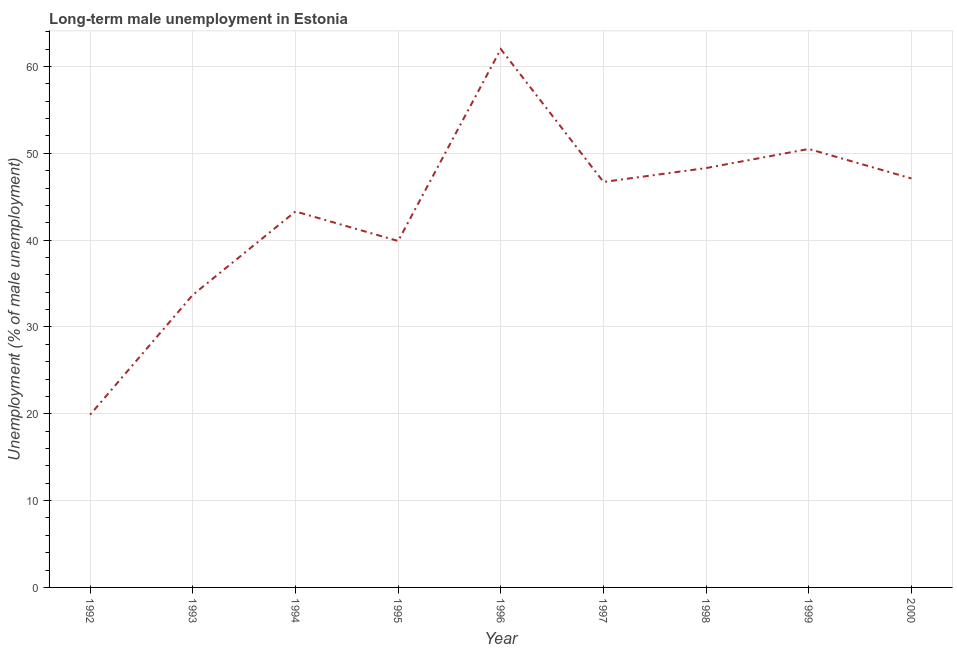What is the long-term male unemployment in 1998?
Ensure brevity in your answer.  48.3. Across all years, what is the minimum long-term male unemployment?
Your answer should be compact. 19.9. In which year was the long-term male unemployment maximum?
Offer a terse response. 1996. What is the sum of the long-term male unemployment?
Give a very brief answer. 391.4. What is the difference between the long-term male unemployment in 1994 and 1995?
Provide a short and direct response. 3.4. What is the average long-term male unemployment per year?
Give a very brief answer. 43.49. What is the median long-term male unemployment?
Offer a terse response. 46.7. In how many years, is the long-term male unemployment greater than 28 %?
Provide a short and direct response. 8. What is the ratio of the long-term male unemployment in 1997 to that in 1999?
Provide a succinct answer. 0.92. Is the long-term male unemployment in 1996 less than that in 1999?
Provide a succinct answer. No. What is the difference between the highest and the lowest long-term male unemployment?
Your answer should be compact. 42.1. In how many years, is the long-term male unemployment greater than the average long-term male unemployment taken over all years?
Your response must be concise. 5. How many lines are there?
Offer a terse response. 1. How many years are there in the graph?
Provide a succinct answer. 9. What is the difference between two consecutive major ticks on the Y-axis?
Make the answer very short. 10. Does the graph contain any zero values?
Make the answer very short. No. What is the title of the graph?
Provide a short and direct response. Long-term male unemployment in Estonia. What is the label or title of the X-axis?
Provide a succinct answer. Year. What is the label or title of the Y-axis?
Your response must be concise. Unemployment (% of male unemployment). What is the Unemployment (% of male unemployment) in 1992?
Make the answer very short. 19.9. What is the Unemployment (% of male unemployment) in 1993?
Your response must be concise. 33.7. What is the Unemployment (% of male unemployment) of 1994?
Offer a very short reply. 43.3. What is the Unemployment (% of male unemployment) in 1995?
Your response must be concise. 39.9. What is the Unemployment (% of male unemployment) in 1997?
Offer a terse response. 46.7. What is the Unemployment (% of male unemployment) of 1998?
Offer a terse response. 48.3. What is the Unemployment (% of male unemployment) of 1999?
Provide a short and direct response. 50.5. What is the Unemployment (% of male unemployment) of 2000?
Provide a short and direct response. 47.1. What is the difference between the Unemployment (% of male unemployment) in 1992 and 1993?
Keep it short and to the point. -13.8. What is the difference between the Unemployment (% of male unemployment) in 1992 and 1994?
Your response must be concise. -23.4. What is the difference between the Unemployment (% of male unemployment) in 1992 and 1996?
Offer a very short reply. -42.1. What is the difference between the Unemployment (% of male unemployment) in 1992 and 1997?
Offer a terse response. -26.8. What is the difference between the Unemployment (% of male unemployment) in 1992 and 1998?
Give a very brief answer. -28.4. What is the difference between the Unemployment (% of male unemployment) in 1992 and 1999?
Make the answer very short. -30.6. What is the difference between the Unemployment (% of male unemployment) in 1992 and 2000?
Provide a succinct answer. -27.2. What is the difference between the Unemployment (% of male unemployment) in 1993 and 1994?
Offer a terse response. -9.6. What is the difference between the Unemployment (% of male unemployment) in 1993 and 1995?
Make the answer very short. -6.2. What is the difference between the Unemployment (% of male unemployment) in 1993 and 1996?
Provide a short and direct response. -28.3. What is the difference between the Unemployment (% of male unemployment) in 1993 and 1998?
Keep it short and to the point. -14.6. What is the difference between the Unemployment (% of male unemployment) in 1993 and 1999?
Your answer should be very brief. -16.8. What is the difference between the Unemployment (% of male unemployment) in 1994 and 1996?
Keep it short and to the point. -18.7. What is the difference between the Unemployment (% of male unemployment) in 1994 and 1997?
Offer a very short reply. -3.4. What is the difference between the Unemployment (% of male unemployment) in 1994 and 1999?
Your answer should be very brief. -7.2. What is the difference between the Unemployment (% of male unemployment) in 1994 and 2000?
Give a very brief answer. -3.8. What is the difference between the Unemployment (% of male unemployment) in 1995 and 1996?
Make the answer very short. -22.1. What is the difference between the Unemployment (% of male unemployment) in 1995 and 1997?
Your answer should be very brief. -6.8. What is the difference between the Unemployment (% of male unemployment) in 1995 and 1998?
Keep it short and to the point. -8.4. What is the difference between the Unemployment (% of male unemployment) in 1995 and 1999?
Offer a terse response. -10.6. What is the difference between the Unemployment (% of male unemployment) in 1996 and 1998?
Offer a very short reply. 13.7. What is the difference between the Unemployment (% of male unemployment) in 1996 and 2000?
Make the answer very short. 14.9. What is the difference between the Unemployment (% of male unemployment) in 1997 and 1999?
Give a very brief answer. -3.8. What is the difference between the Unemployment (% of male unemployment) in 1998 and 2000?
Offer a very short reply. 1.2. What is the difference between the Unemployment (% of male unemployment) in 1999 and 2000?
Offer a very short reply. 3.4. What is the ratio of the Unemployment (% of male unemployment) in 1992 to that in 1993?
Your answer should be compact. 0.59. What is the ratio of the Unemployment (% of male unemployment) in 1992 to that in 1994?
Give a very brief answer. 0.46. What is the ratio of the Unemployment (% of male unemployment) in 1992 to that in 1995?
Offer a terse response. 0.5. What is the ratio of the Unemployment (% of male unemployment) in 1992 to that in 1996?
Offer a very short reply. 0.32. What is the ratio of the Unemployment (% of male unemployment) in 1992 to that in 1997?
Offer a terse response. 0.43. What is the ratio of the Unemployment (% of male unemployment) in 1992 to that in 1998?
Your response must be concise. 0.41. What is the ratio of the Unemployment (% of male unemployment) in 1992 to that in 1999?
Give a very brief answer. 0.39. What is the ratio of the Unemployment (% of male unemployment) in 1992 to that in 2000?
Offer a terse response. 0.42. What is the ratio of the Unemployment (% of male unemployment) in 1993 to that in 1994?
Your response must be concise. 0.78. What is the ratio of the Unemployment (% of male unemployment) in 1993 to that in 1995?
Provide a short and direct response. 0.84. What is the ratio of the Unemployment (% of male unemployment) in 1993 to that in 1996?
Your answer should be very brief. 0.54. What is the ratio of the Unemployment (% of male unemployment) in 1993 to that in 1997?
Offer a very short reply. 0.72. What is the ratio of the Unemployment (% of male unemployment) in 1993 to that in 1998?
Your response must be concise. 0.7. What is the ratio of the Unemployment (% of male unemployment) in 1993 to that in 1999?
Offer a very short reply. 0.67. What is the ratio of the Unemployment (% of male unemployment) in 1993 to that in 2000?
Your response must be concise. 0.71. What is the ratio of the Unemployment (% of male unemployment) in 1994 to that in 1995?
Keep it short and to the point. 1.08. What is the ratio of the Unemployment (% of male unemployment) in 1994 to that in 1996?
Make the answer very short. 0.7. What is the ratio of the Unemployment (% of male unemployment) in 1994 to that in 1997?
Offer a very short reply. 0.93. What is the ratio of the Unemployment (% of male unemployment) in 1994 to that in 1998?
Your response must be concise. 0.9. What is the ratio of the Unemployment (% of male unemployment) in 1994 to that in 1999?
Your answer should be compact. 0.86. What is the ratio of the Unemployment (% of male unemployment) in 1994 to that in 2000?
Provide a short and direct response. 0.92. What is the ratio of the Unemployment (% of male unemployment) in 1995 to that in 1996?
Offer a very short reply. 0.64. What is the ratio of the Unemployment (% of male unemployment) in 1995 to that in 1997?
Offer a very short reply. 0.85. What is the ratio of the Unemployment (% of male unemployment) in 1995 to that in 1998?
Your answer should be very brief. 0.83. What is the ratio of the Unemployment (% of male unemployment) in 1995 to that in 1999?
Provide a short and direct response. 0.79. What is the ratio of the Unemployment (% of male unemployment) in 1995 to that in 2000?
Keep it short and to the point. 0.85. What is the ratio of the Unemployment (% of male unemployment) in 1996 to that in 1997?
Keep it short and to the point. 1.33. What is the ratio of the Unemployment (% of male unemployment) in 1996 to that in 1998?
Offer a very short reply. 1.28. What is the ratio of the Unemployment (% of male unemployment) in 1996 to that in 1999?
Your answer should be compact. 1.23. What is the ratio of the Unemployment (% of male unemployment) in 1996 to that in 2000?
Provide a short and direct response. 1.32. What is the ratio of the Unemployment (% of male unemployment) in 1997 to that in 1999?
Your answer should be very brief. 0.93. What is the ratio of the Unemployment (% of male unemployment) in 1998 to that in 1999?
Provide a succinct answer. 0.96. What is the ratio of the Unemployment (% of male unemployment) in 1999 to that in 2000?
Your response must be concise. 1.07. 